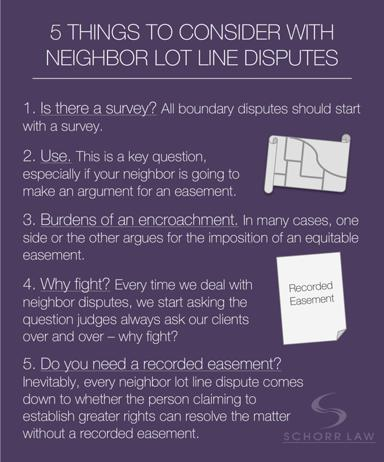Can you explain what a recorded easement is as mentioned in the text? Certainly! A recorded easement is a legal right that is officially documented and grants one party use of another party's property for a specific purpose, such as access to a road or use of utility lines. The text suggests that having a recorded easement can be crucial in resolving disputes over property rights. 